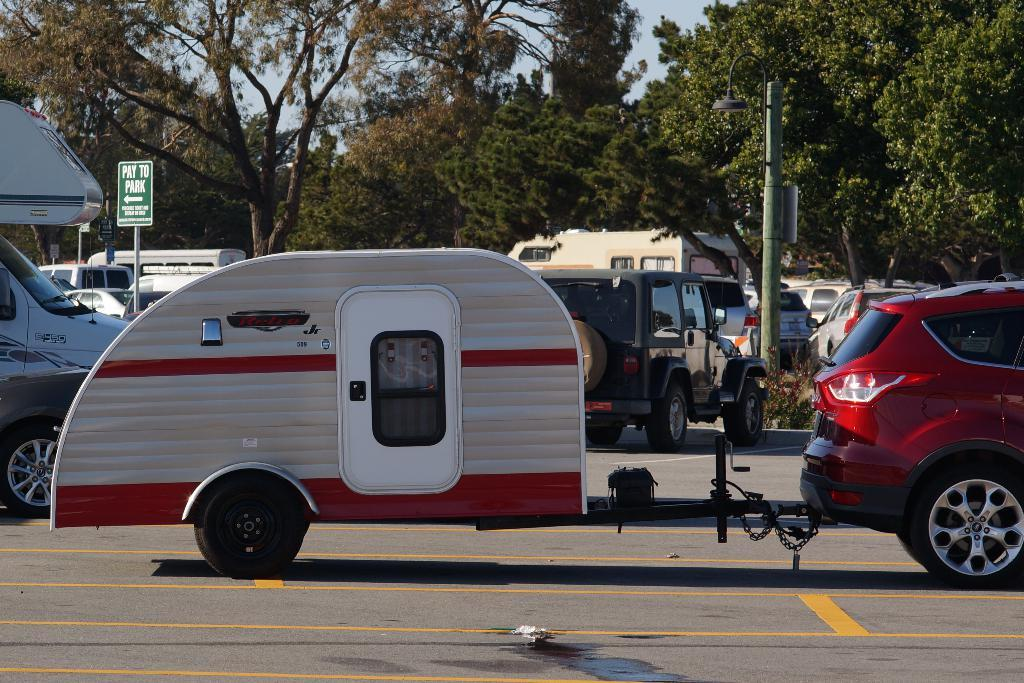What types of objects are present in the image? There are vehicles, sign boards, and a pole in the image. What else can be seen in the image besides the objects mentioned? There are trees in the image. How is the sky depicted in the image? The sky is white and blue in color. How many ants can be seen crawling on the vehicles in the image? There are no ants present in the image; it features vehicles, sign boards, a pole, trees, and a white and blue sky. What type of weather condition is depicted in the image, such as a crowd or fog? The image does not depict any weather conditions like a crowd or fog; it only shows vehicles, sign boards, a pole, trees, and a white and blue sky. 